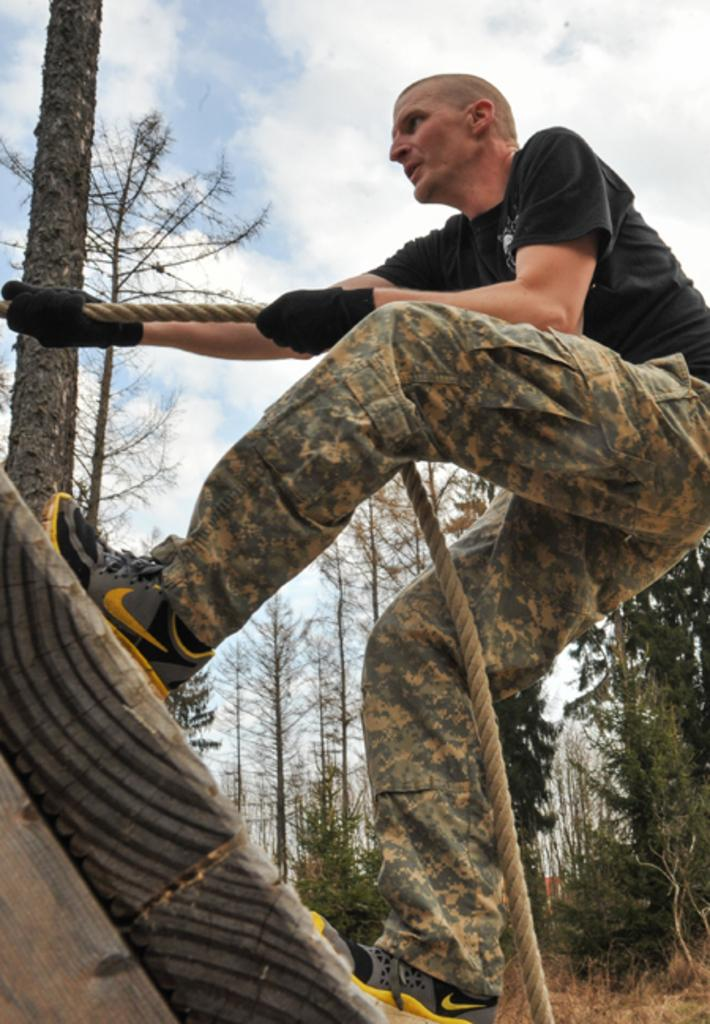What is the man in the image doing? The man is climbing in the image. What is the man holding while climbing? The man is holding a rope in the image. What protective gear is the man wearing? The man is wearing gloves in the image. What can be seen in the background of the image? There are trees, grass, and the sky visible in the background of the image. What type of shoes is the man wearing while climbing in the image? There is no mention of shoes in the image; the man is wearing gloves. Can you tell me how many eggs are in the eggnog that the man is holding in the image? There is no eggnog or eggs present in the image; the man is holding a rope while climbing. 